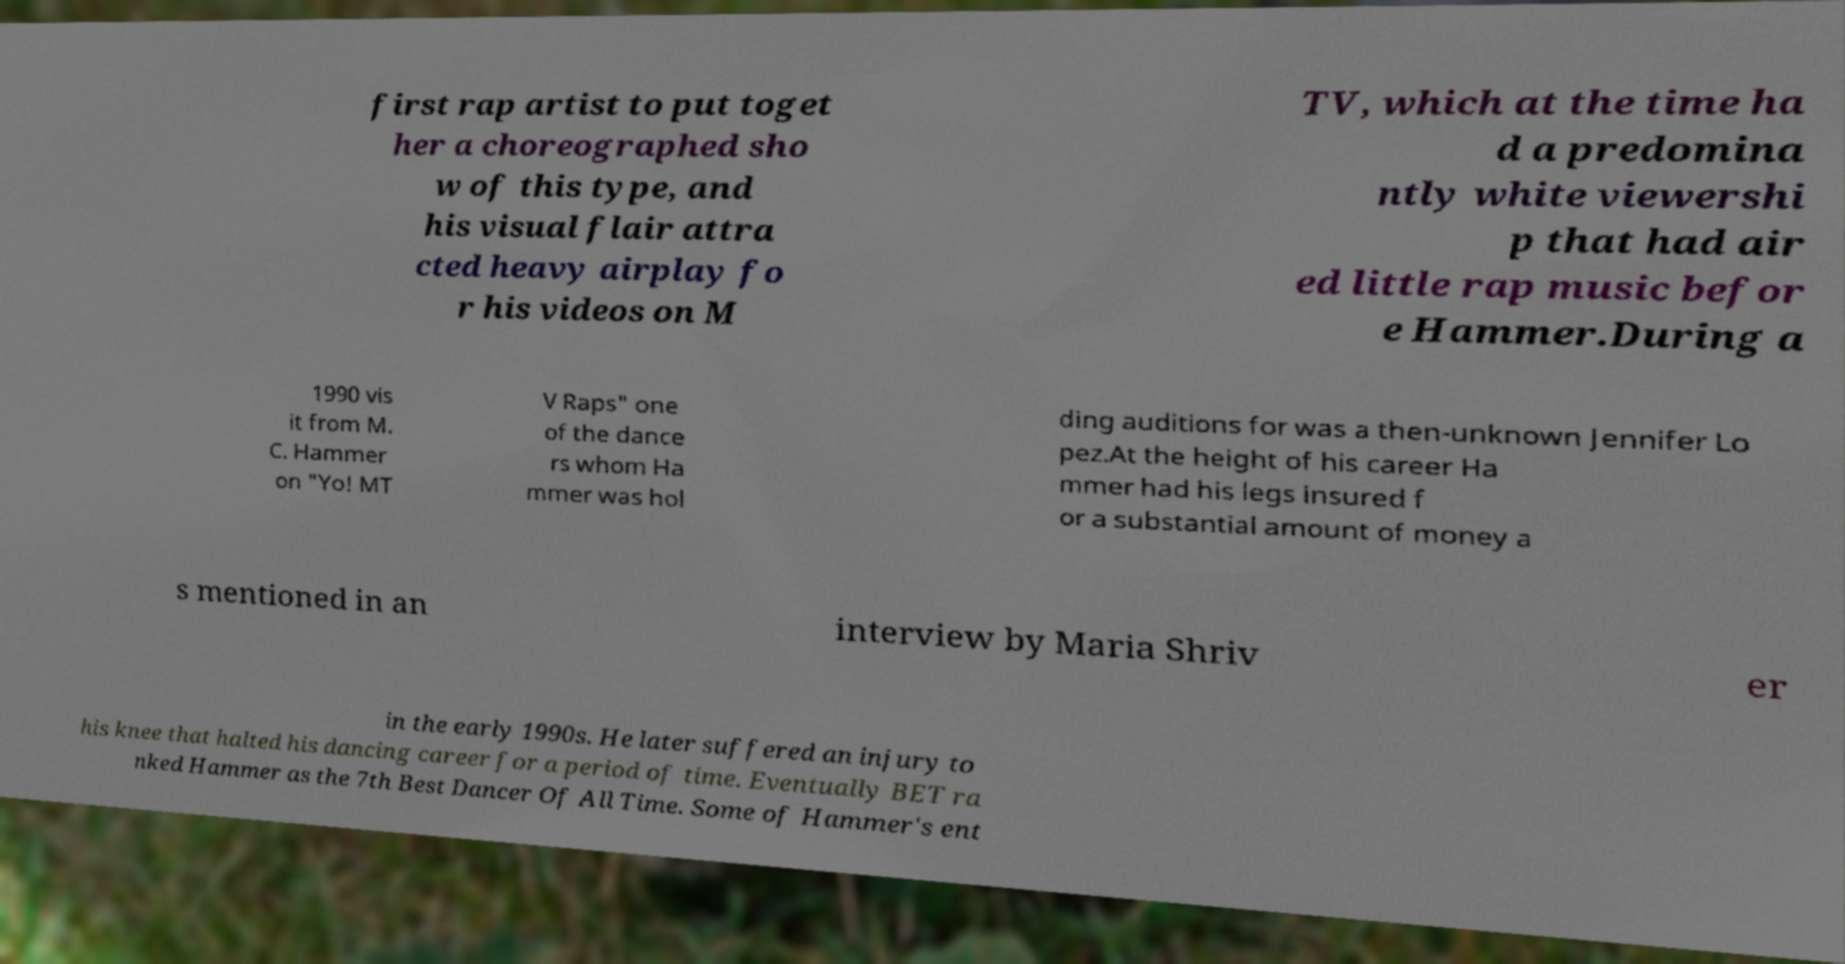Please identify and transcribe the text found in this image. first rap artist to put toget her a choreographed sho w of this type, and his visual flair attra cted heavy airplay fo r his videos on M TV, which at the time ha d a predomina ntly white viewershi p that had air ed little rap music befor e Hammer.During a 1990 vis it from M. C. Hammer on "Yo! MT V Raps" one of the dance rs whom Ha mmer was hol ding auditions for was a then-unknown Jennifer Lo pez.At the height of his career Ha mmer had his legs insured f or a substantial amount of money a s mentioned in an interview by Maria Shriv er in the early 1990s. He later suffered an injury to his knee that halted his dancing career for a period of time. Eventually BET ra nked Hammer as the 7th Best Dancer Of All Time. Some of Hammer's ent 